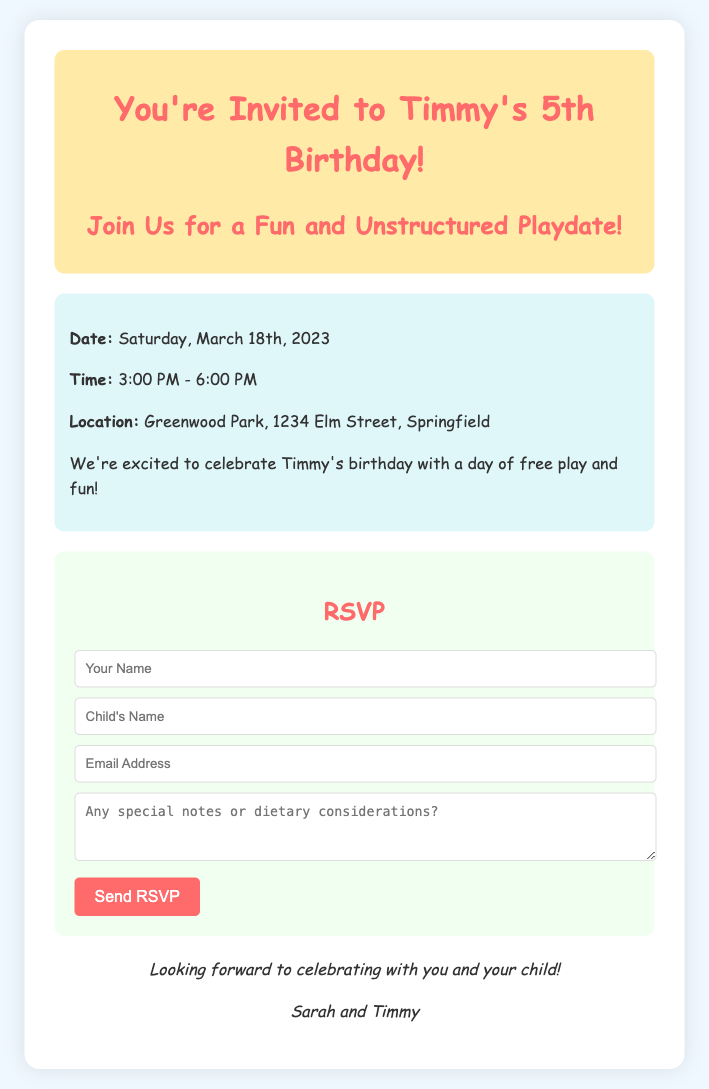What date is Timmy's birthday party? The document specifies that Timmy's birthday party is on Saturday, March 18th, 2023.
Answer: Saturday, March 18th, 2023 What time does the party start? The document indicates that the party starts at 3:00 PM.
Answer: 3:00 PM Where is the party located? The document provides the location as Greenwood Park, 1234 Elm Street, Springfield.
Answer: Greenwood Park, 1234 Elm Street, Springfield Who are the hosts of the party? The document states that the hosts are Sarah and Timmy.
Answer: Sarah and Timmy What type of playdate is being offered? The invitation mentions that it will be a fun and unstructured playdate.
Answer: Fun and unstructured playdate What should guests provide in the RSVP? The RSVP includes a section for guests to write any special notes or dietary considerations.
Answer: Special notes or dietary considerations How long will the party last? The document shows that the party is scheduled to last for 3 hours, from 3:00 PM to 6:00 PM.
Answer: 3 hours What is the color scheme of the card? The document's style indicates a light pastel color scheme, with hues like #f0f8ff and #ff6b6b featured prominently.
Answer: Light pastel colors What do the hosts encourage in terms of play? The document emphasizes that the celebration will include a day of free play and fun.
Answer: Free play and fun 